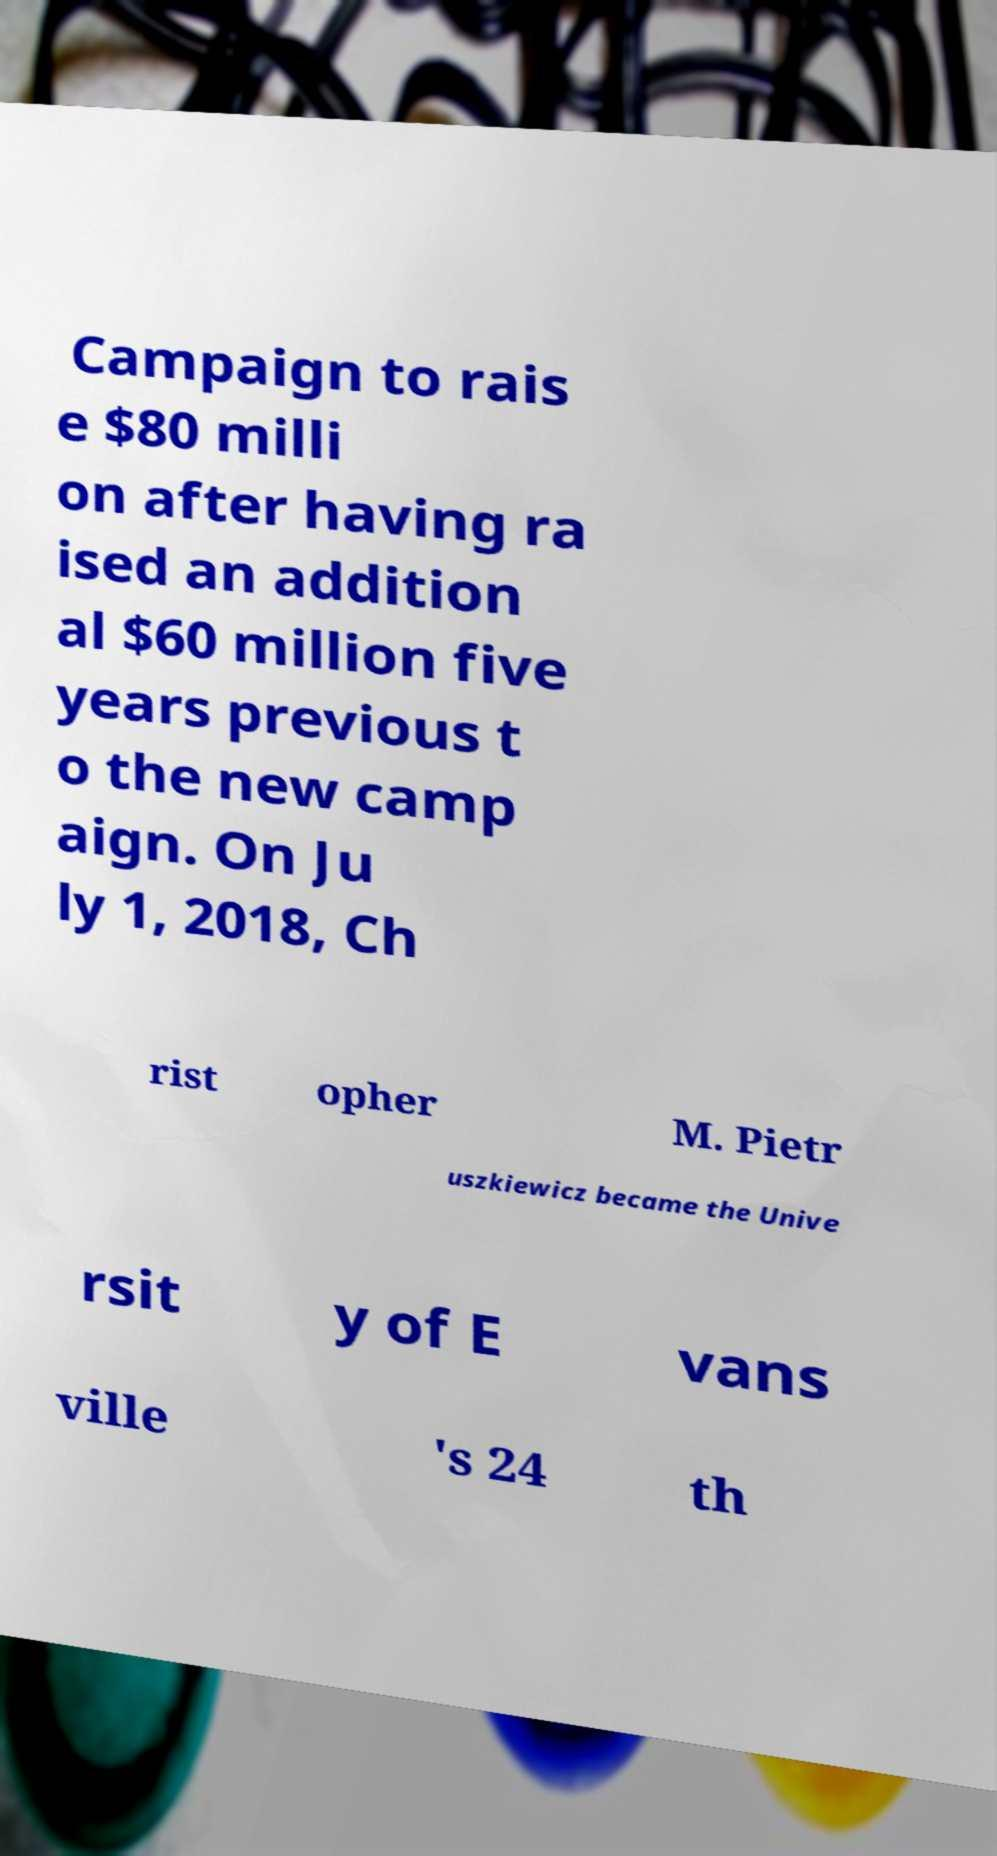Could you assist in decoding the text presented in this image and type it out clearly? Campaign to rais e $80 milli on after having ra ised an addition al $60 million five years previous t o the new camp aign. On Ju ly 1, 2018, Ch rist opher M. Pietr uszkiewicz became the Unive rsit y of E vans ville 's 24 th 